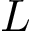Convert formula to latex. <formula><loc_0><loc_0><loc_500><loc_500>L</formula> 